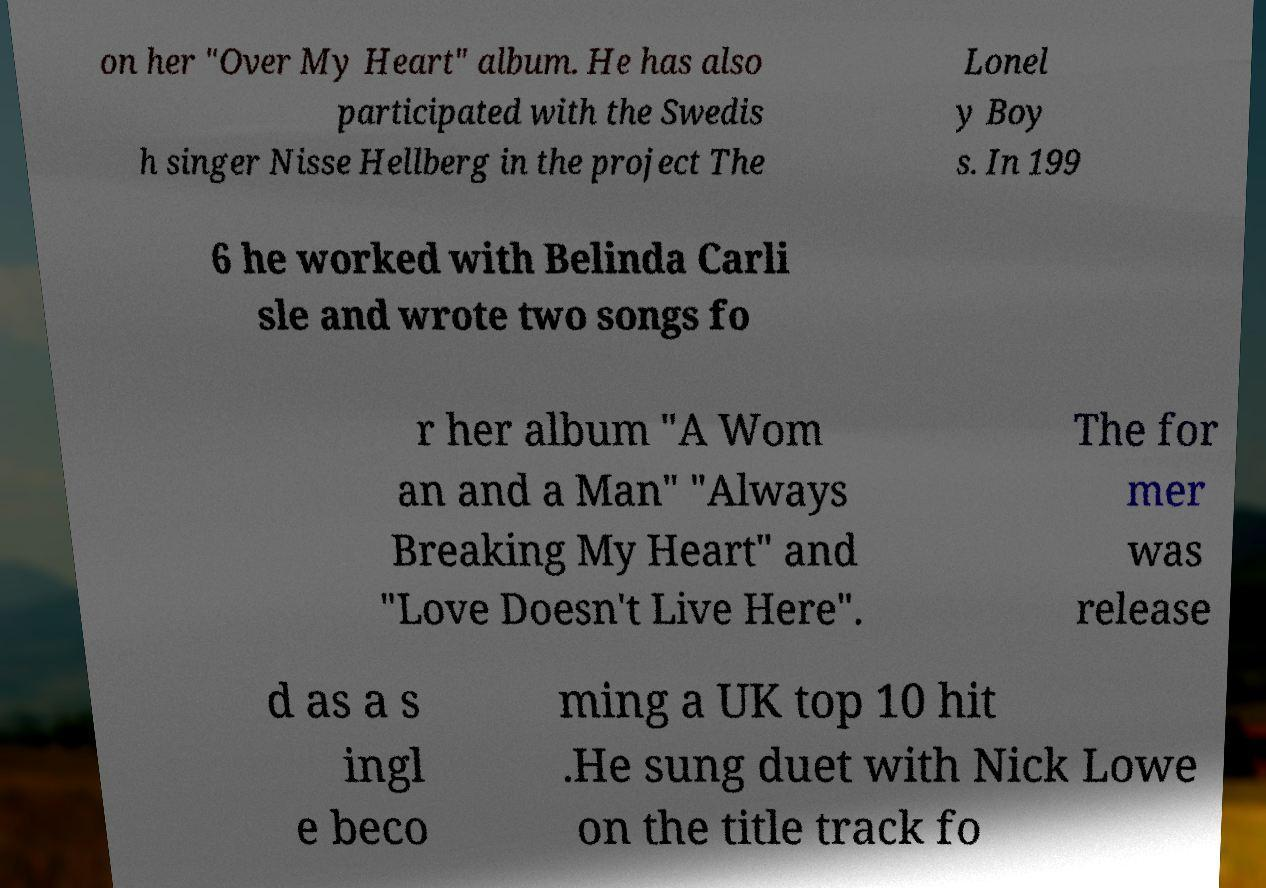Can you read and provide the text displayed in the image?This photo seems to have some interesting text. Can you extract and type it out for me? on her "Over My Heart" album. He has also participated with the Swedis h singer Nisse Hellberg in the project The Lonel y Boy s. In 199 6 he worked with Belinda Carli sle and wrote two songs fo r her album "A Wom an and a Man" "Always Breaking My Heart" and "Love Doesn't Live Here". The for mer was release d as a s ingl e beco ming a UK top 10 hit .He sung duet with Nick Lowe on the title track fo 